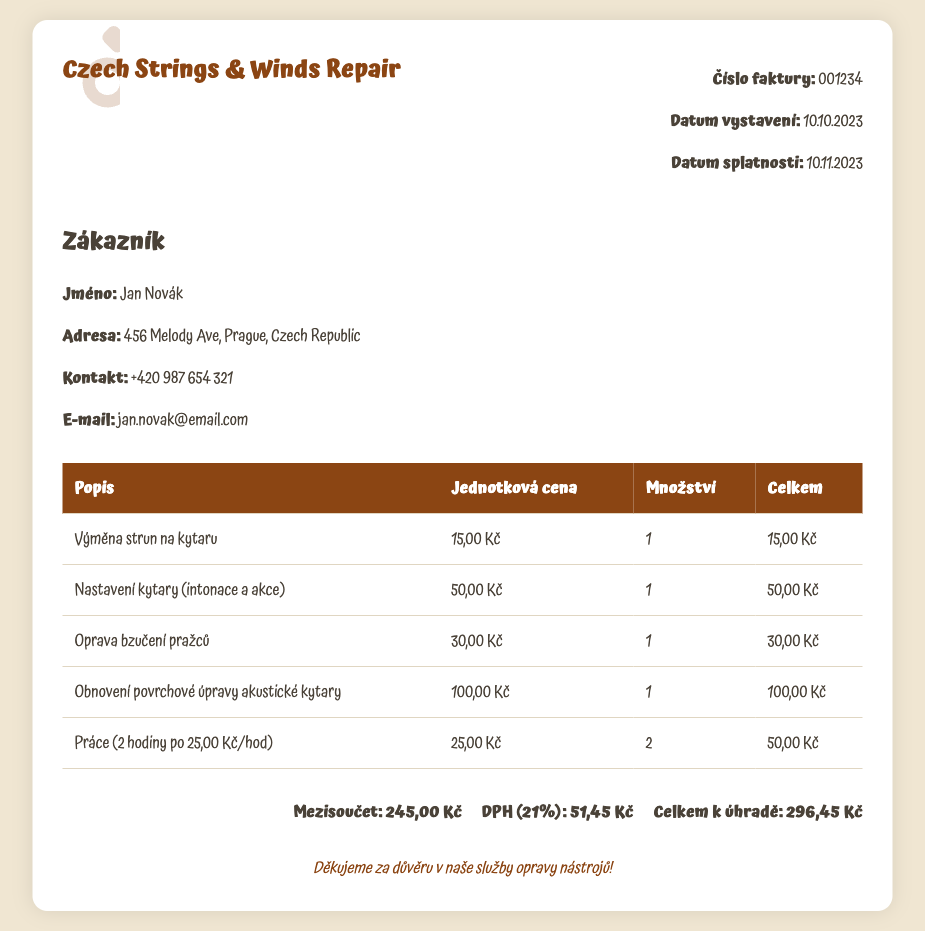what is the invoice number? The invoice number is a specific identifier for this document, provided clearly near the top.
Answer: 001234 what is the issue date of the invoice? The issue date indicates when the invoice was created, listed in the invoice details section.
Answer: 10.10.2023 who is the customer? The customer's name is stated in the customer details section, identifying who the services were rendered for.
Answer: Jan Novák how many hours of labor were charged? The hours of labor indicate the total time spent on the job, specified in the itemized list.
Answer: 2 what is the subtotal amount before tax? The subtotal represents the total of all charges before tax is applied, found in the total section.
Answer: 245,00 Kč what percentage is the VAT on this invoice? The VAT percentage is common across invoices and is found in the total section.
Answer: 21% what is the total amount due? The total amount due summarizes all charges including VAT, found in the total section.
Answer: 296,45 Kč what services were provided for the acoustic guitar? The services list several specific repairs and maintenance tasks conducted on the instrument, detailed in the itemized table.
Answer: Výměna strun, Nastavení kytary, Oprava bzučení, Obnovení povrchové úpravy what is the contact email for the customer? The email is provided under the customer's contact details, allowing for communication regarding the invoice.
Answer: jan.novak@email.com 